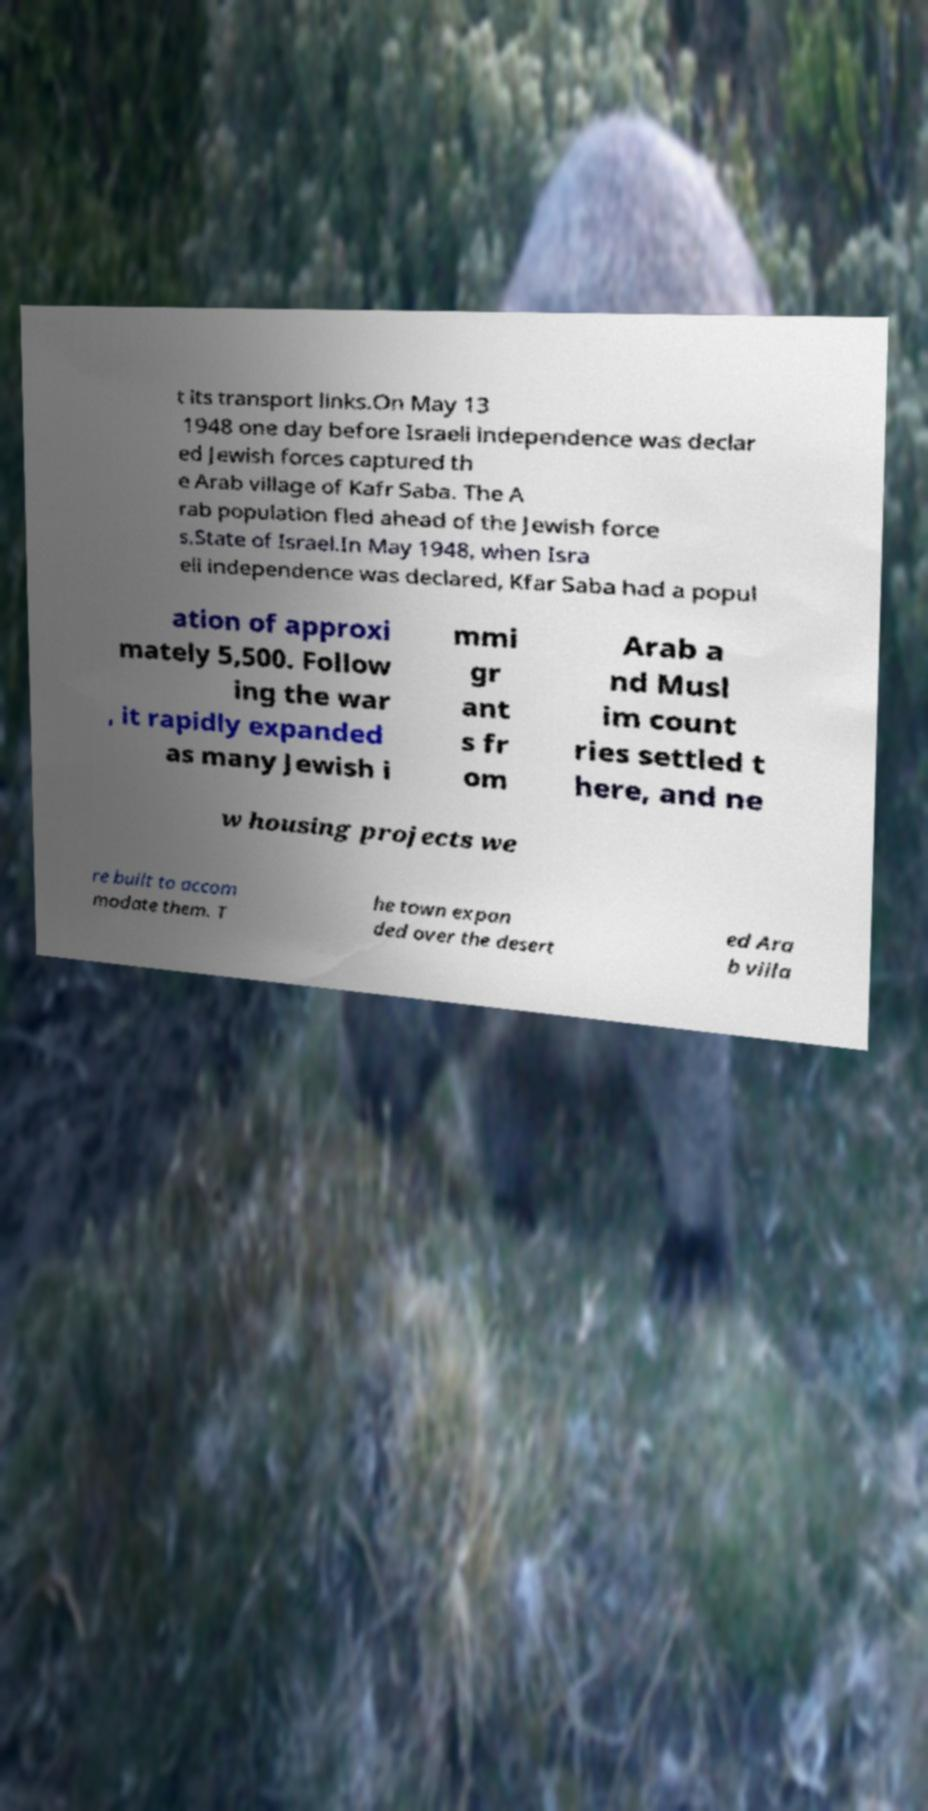Could you extract and type out the text from this image? t its transport links.On May 13 1948 one day before Israeli independence was declar ed Jewish forces captured th e Arab village of Kafr Saba. The A rab population fled ahead of the Jewish force s.State of Israel.In May 1948, when Isra eli independence was declared, Kfar Saba had a popul ation of approxi mately 5,500. Follow ing the war , it rapidly expanded as many Jewish i mmi gr ant s fr om Arab a nd Musl im count ries settled t here, and ne w housing projects we re built to accom modate them. T he town expan ded over the desert ed Ara b villa 